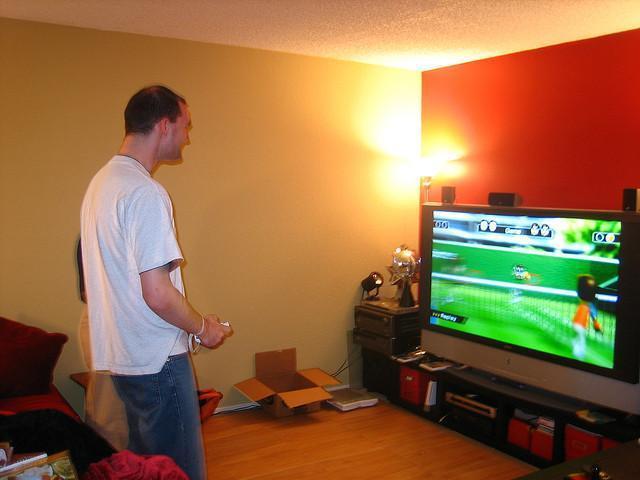How many lights are on the ceiling?
Give a very brief answer. 0. How many people in the room?
Give a very brief answer. 2. 